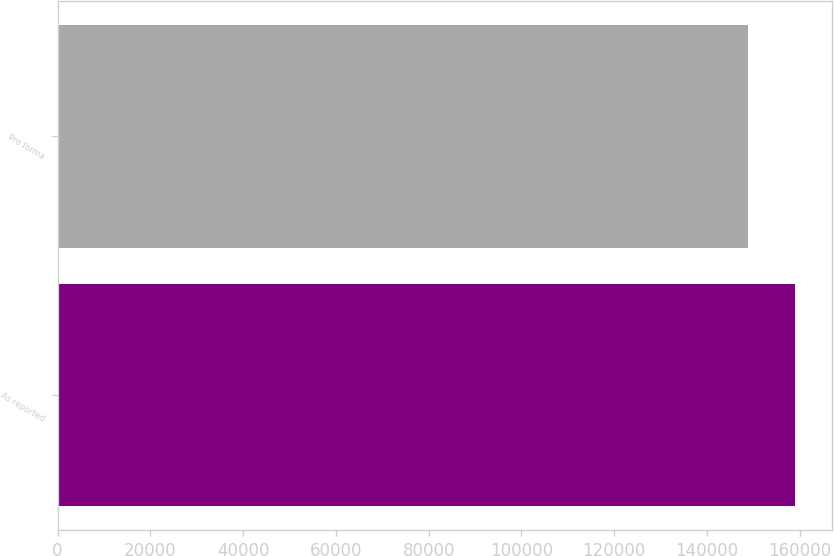<chart> <loc_0><loc_0><loc_500><loc_500><bar_chart><fcel>As reported<fcel>Pro forma<nl><fcel>159068<fcel>148897<nl></chart> 